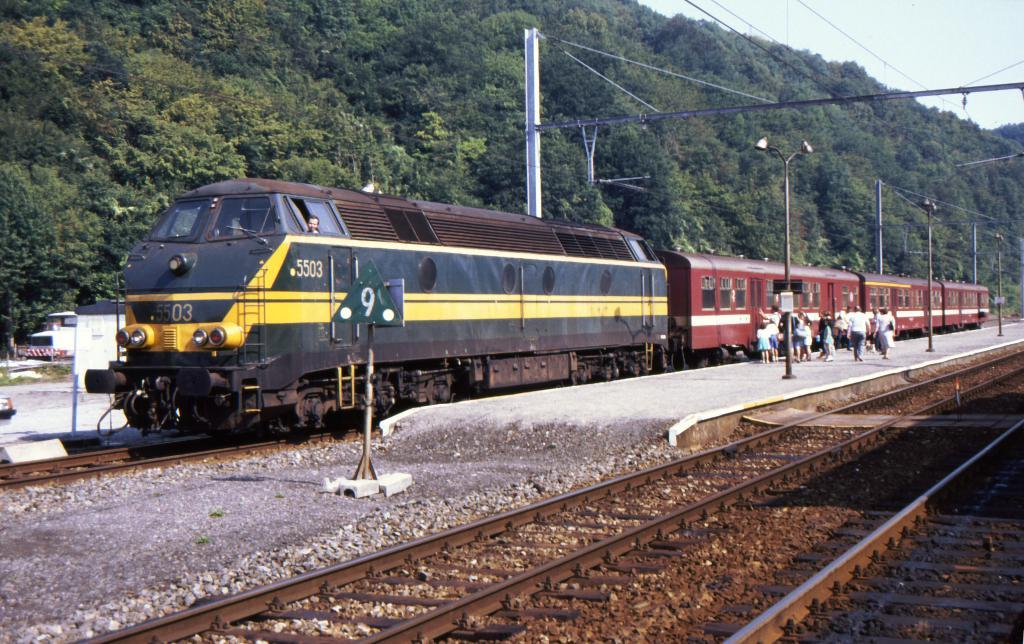Provide a one-sentence caption for the provided image. Train number 5503 stops to pick up passengers. 